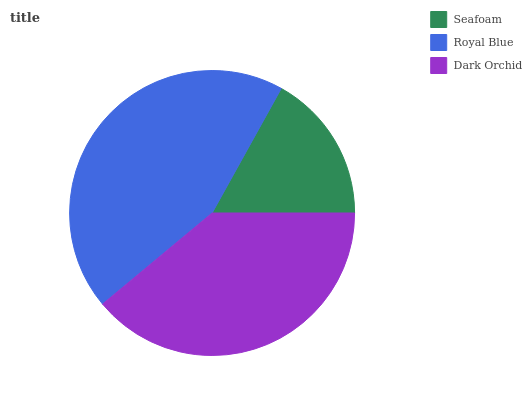Is Seafoam the minimum?
Answer yes or no. Yes. Is Royal Blue the maximum?
Answer yes or no. Yes. Is Dark Orchid the minimum?
Answer yes or no. No. Is Dark Orchid the maximum?
Answer yes or no. No. Is Royal Blue greater than Dark Orchid?
Answer yes or no. Yes. Is Dark Orchid less than Royal Blue?
Answer yes or no. Yes. Is Dark Orchid greater than Royal Blue?
Answer yes or no. No. Is Royal Blue less than Dark Orchid?
Answer yes or no. No. Is Dark Orchid the high median?
Answer yes or no. Yes. Is Dark Orchid the low median?
Answer yes or no. Yes. Is Royal Blue the high median?
Answer yes or no. No. Is Royal Blue the low median?
Answer yes or no. No. 